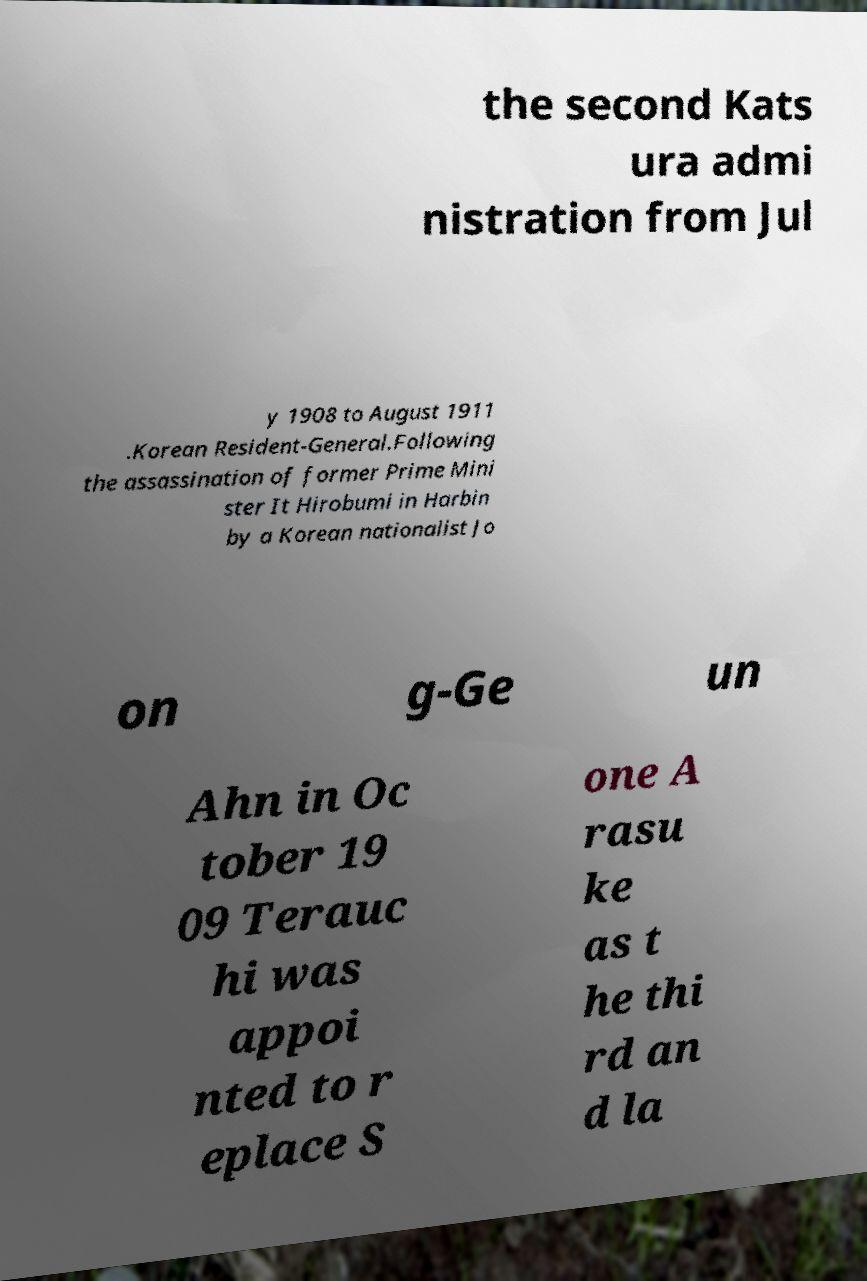Please read and relay the text visible in this image. What does it say? the second Kats ura admi nistration from Jul y 1908 to August 1911 .Korean Resident-General.Following the assassination of former Prime Mini ster It Hirobumi in Harbin by a Korean nationalist Jo on g-Ge un Ahn in Oc tober 19 09 Terauc hi was appoi nted to r eplace S one A rasu ke as t he thi rd an d la 